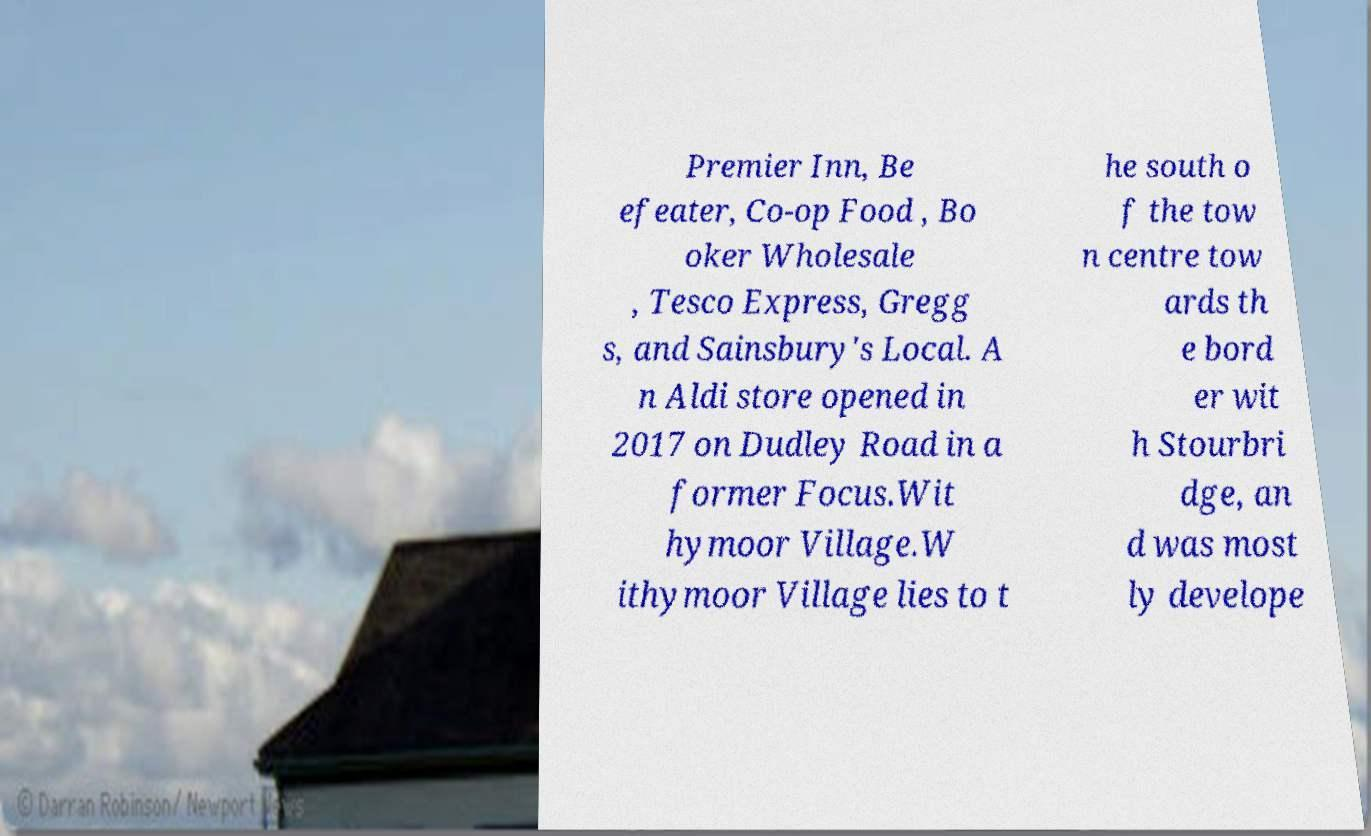What messages or text are displayed in this image? I need them in a readable, typed format. Premier Inn, Be efeater, Co-op Food , Bo oker Wholesale , Tesco Express, Gregg s, and Sainsbury's Local. A n Aldi store opened in 2017 on Dudley Road in a former Focus.Wit hymoor Village.W ithymoor Village lies to t he south o f the tow n centre tow ards th e bord er wit h Stourbri dge, an d was most ly develope 